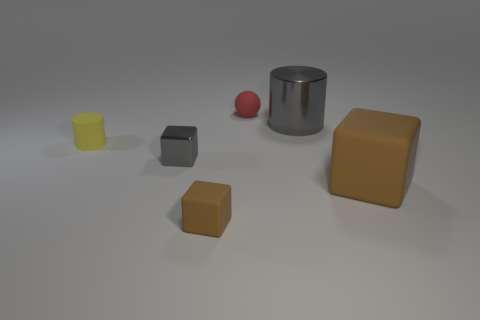What shapes can you identify in the image? The image contains several different shapes: there is a cylinder, spheres, and several cubes with varying sizes and colors. What could these objects represent in a real-world setting? These objects could represent everyday items, such as containers, balls, and blocks. They might be used in a variety of settings, potentially as simplistic models for educational purposes or as part of a minimalist art piece. 